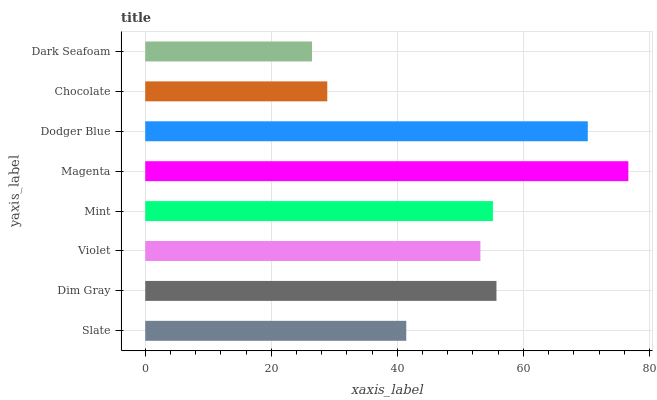Is Dark Seafoam the minimum?
Answer yes or no. Yes. Is Magenta the maximum?
Answer yes or no. Yes. Is Dim Gray the minimum?
Answer yes or no. No. Is Dim Gray the maximum?
Answer yes or no. No. Is Dim Gray greater than Slate?
Answer yes or no. Yes. Is Slate less than Dim Gray?
Answer yes or no. Yes. Is Slate greater than Dim Gray?
Answer yes or no. No. Is Dim Gray less than Slate?
Answer yes or no. No. Is Mint the high median?
Answer yes or no. Yes. Is Violet the low median?
Answer yes or no. Yes. Is Violet the high median?
Answer yes or no. No. Is Dodger Blue the low median?
Answer yes or no. No. 